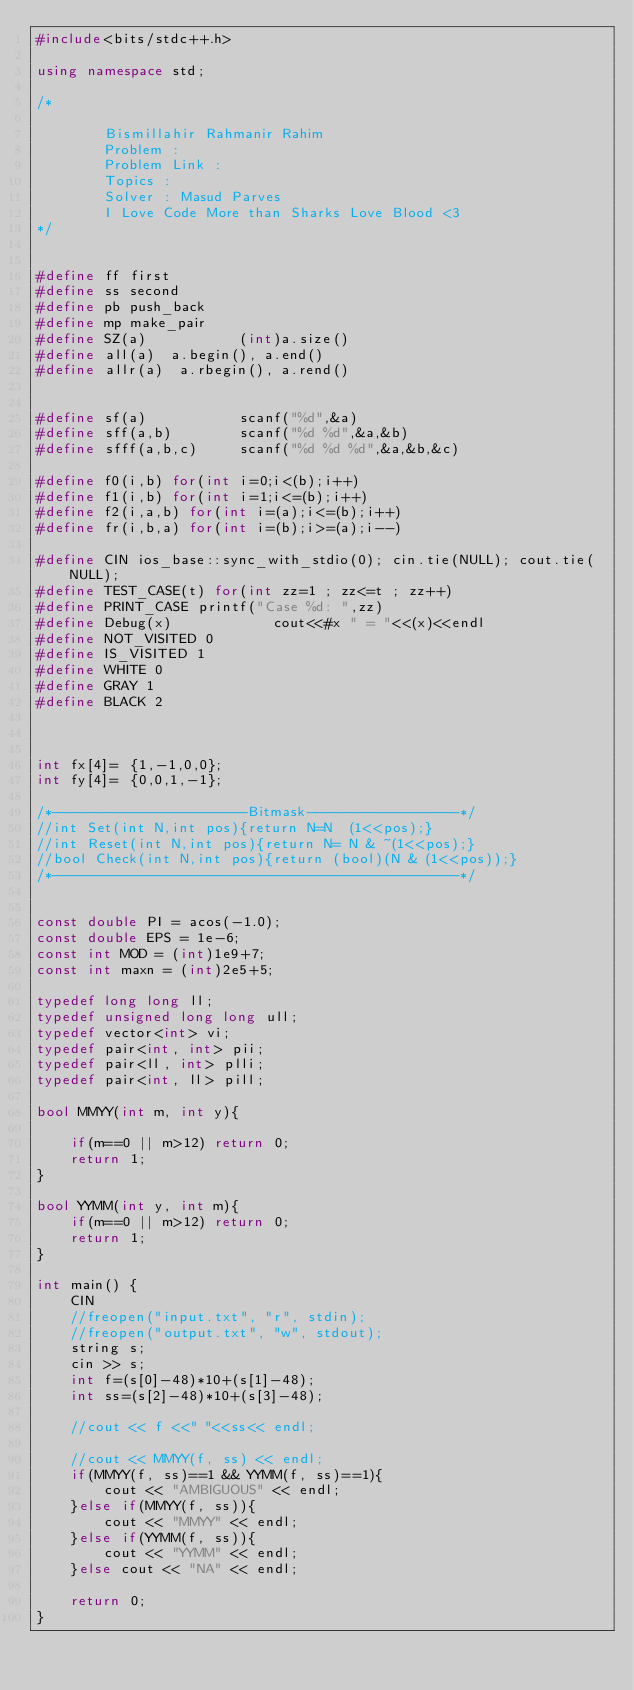Convert code to text. <code><loc_0><loc_0><loc_500><loc_500><_C++_>#include<bits/stdc++.h>

using namespace std;

/*

        Bismillahir Rahmanir Rahim
        Problem :
        Problem Link :
        Topics :
        Solver : Masud Parves
        I Love Code More than Sharks Love Blood <3
*/


#define ff first
#define ss second
#define pb push_back
#define mp make_pair
#define SZ(a)           (int)a.size()
#define all(a)  a.begin(), a.end()
#define allr(a)  a.rbegin(), a.rend()


#define sf(a)           scanf("%d",&a)
#define sff(a,b)        scanf("%d %d",&a,&b)
#define sfff(a,b,c)     scanf("%d %d %d",&a,&b,&c)

#define f0(i,b) for(int i=0;i<(b);i++)
#define f1(i,b) for(int i=1;i<=(b);i++)
#define f2(i,a,b) for(int i=(a);i<=(b);i++)
#define fr(i,b,a) for(int i=(b);i>=(a);i--)

#define CIN ios_base::sync_with_stdio(0); cin.tie(NULL); cout.tie(NULL);
#define TEST_CASE(t) for(int zz=1 ; zz<=t ; zz++)
#define PRINT_CASE printf("Case %d: ",zz)
#define Debug(x)            cout<<#x " = "<<(x)<<endl
#define NOT_VISITED 0
#define IS_VISITED 1
#define WHITE 0
#define GRAY 1
#define BLACK 2



int fx[4]= {1,-1,0,0};
int fy[4]= {0,0,1,-1};

/*-----------------------Bitmask------------------*/
//int Set(int N,int pos){return N=N  (1<<pos);}
//int Reset(int N,int pos){return N= N & ~(1<<pos);}
//bool Check(int N,int pos){return (bool)(N & (1<<pos));}
/*------------------------------------------------*/


const double PI = acos(-1.0);
const double EPS = 1e-6;
const int MOD = (int)1e9+7;
const int maxn = (int)2e5+5;

typedef long long ll;
typedef unsigned long long ull;
typedef vector<int> vi;
typedef pair<int, int> pii;
typedef pair<ll, int> plli;
typedef pair<int, ll> pill;

bool MMYY(int m, int y){

    if(m==0 || m>12) return 0;
    return 1;
}

bool YYMM(int y, int m){
    if(m==0 || m>12) return 0;
    return 1;
}

int main() {
    CIN
    //freopen("input.txt", "r", stdin);
    //freopen("output.txt", "w", stdout);
    string s;
    cin >> s;
    int f=(s[0]-48)*10+(s[1]-48);
    int ss=(s[2]-48)*10+(s[3]-48);

    //cout << f <<" "<<ss<< endl;

    //cout << MMYY(f, ss) << endl;
    if(MMYY(f, ss)==1 && YYMM(f, ss)==1){
        cout << "AMBIGUOUS" << endl;
    }else if(MMYY(f, ss)){
        cout << "MMYY" << endl;
    }else if(YYMM(f, ss)){
        cout << "YYMM" << endl;
    }else cout << "NA" << endl;

    return 0;
}

</code> 